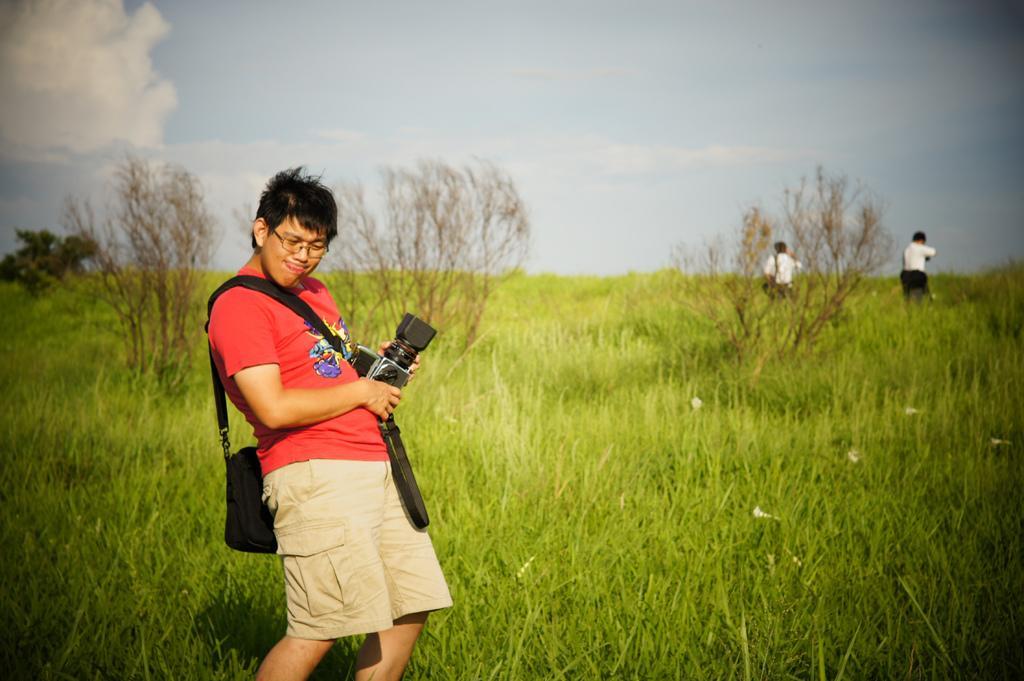Could you give a brief overview of what you see in this image? In the image we can see there is a man standing and he is holding camera in his hand. He is carrying a bag and there are plants on the ground. Behind there are trees and there are people standing on the ground. There is a cloudy sky. 